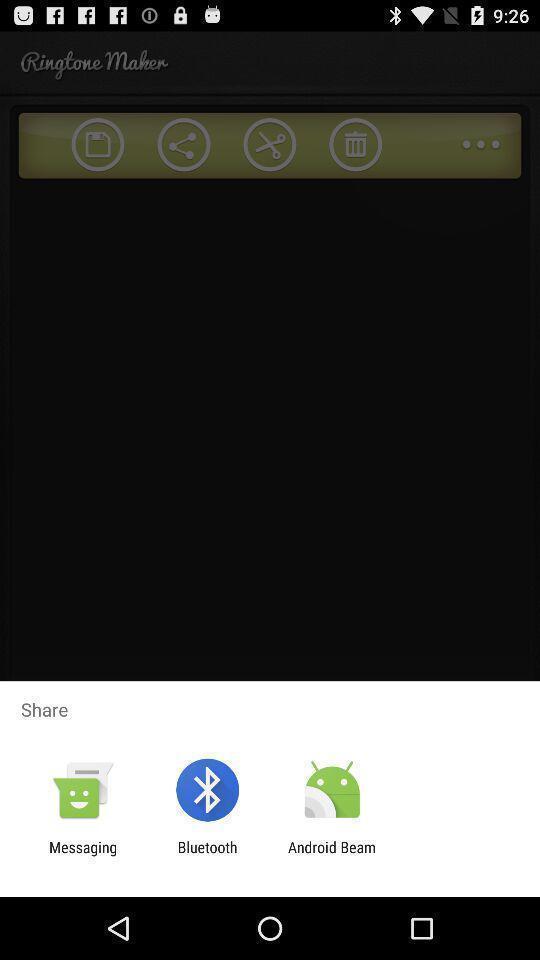Give me a summary of this screen capture. Pop-up widget is showing different sharing apps. 